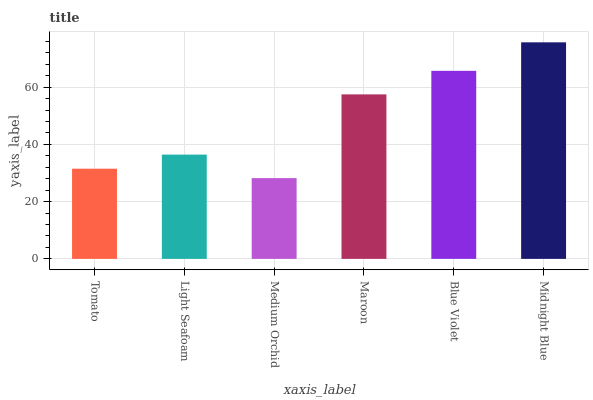Is Medium Orchid the minimum?
Answer yes or no. Yes. Is Midnight Blue the maximum?
Answer yes or no. Yes. Is Light Seafoam the minimum?
Answer yes or no. No. Is Light Seafoam the maximum?
Answer yes or no. No. Is Light Seafoam greater than Tomato?
Answer yes or no. Yes. Is Tomato less than Light Seafoam?
Answer yes or no. Yes. Is Tomato greater than Light Seafoam?
Answer yes or no. No. Is Light Seafoam less than Tomato?
Answer yes or no. No. Is Maroon the high median?
Answer yes or no. Yes. Is Light Seafoam the low median?
Answer yes or no. Yes. Is Light Seafoam the high median?
Answer yes or no. No. Is Medium Orchid the low median?
Answer yes or no. No. 